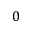<formula> <loc_0><loc_0><loc_500><loc_500>0</formula> 